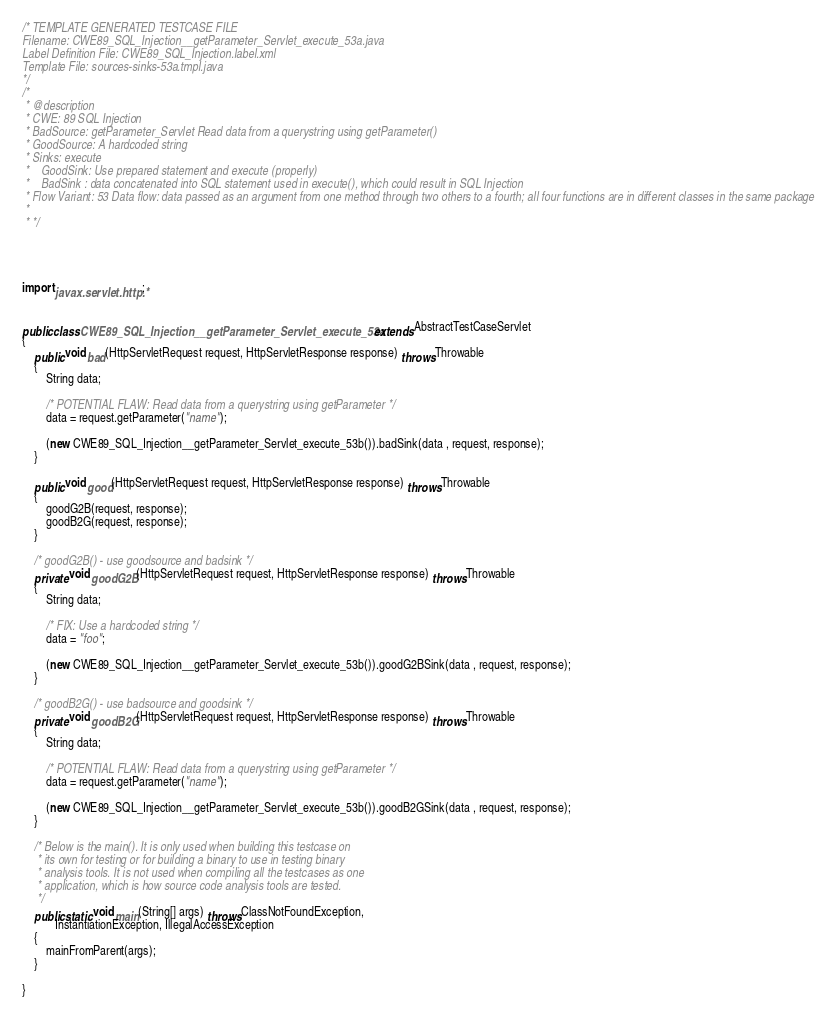<code> <loc_0><loc_0><loc_500><loc_500><_Java_>/* TEMPLATE GENERATED TESTCASE FILE
Filename: CWE89_SQL_Injection__getParameter_Servlet_execute_53a.java
Label Definition File: CWE89_SQL_Injection.label.xml
Template File: sources-sinks-53a.tmpl.java
*/
/*
 * @description
 * CWE: 89 SQL Injection
 * BadSource: getParameter_Servlet Read data from a querystring using getParameter()
 * GoodSource: A hardcoded string
 * Sinks: execute
 *    GoodSink: Use prepared statement and execute (properly)
 *    BadSink : data concatenated into SQL statement used in execute(), which could result in SQL Injection
 * Flow Variant: 53 Data flow: data passed as an argument from one method through two others to a fourth; all four functions are in different classes in the same package
 *
 * */




import javax.servlet.http.*;


public class CWE89_SQL_Injection__getParameter_Servlet_execute_53a extends AbstractTestCaseServlet
{
    public void bad(HttpServletRequest request, HttpServletResponse response) throws Throwable
    {
        String data;

        /* POTENTIAL FLAW: Read data from a querystring using getParameter */
        data = request.getParameter("name");

        (new CWE89_SQL_Injection__getParameter_Servlet_execute_53b()).badSink(data , request, response);
    }

    public void good(HttpServletRequest request, HttpServletResponse response) throws Throwable
    {
        goodG2B(request, response);
        goodB2G(request, response);
    }

    /* goodG2B() - use goodsource and badsink */
    private void goodG2B(HttpServletRequest request, HttpServletResponse response) throws Throwable
    {
        String data;

        /* FIX: Use a hardcoded string */
        data = "foo";

        (new CWE89_SQL_Injection__getParameter_Servlet_execute_53b()).goodG2BSink(data , request, response);
    }

    /* goodB2G() - use badsource and goodsink */
    private void goodB2G(HttpServletRequest request, HttpServletResponse response) throws Throwable
    {
        String data;

        /* POTENTIAL FLAW: Read data from a querystring using getParameter */
        data = request.getParameter("name");

        (new CWE89_SQL_Injection__getParameter_Servlet_execute_53b()).goodB2GSink(data , request, response);
    }

    /* Below is the main(). It is only used when building this testcase on
     * its own for testing or for building a binary to use in testing binary
     * analysis tools. It is not used when compiling all the testcases as one
     * application, which is how source code analysis tools are tested.
     */
    public static void main(String[] args) throws ClassNotFoundException,
           InstantiationException, IllegalAccessException
    {
        mainFromParent(args);
    }

}
</code> 